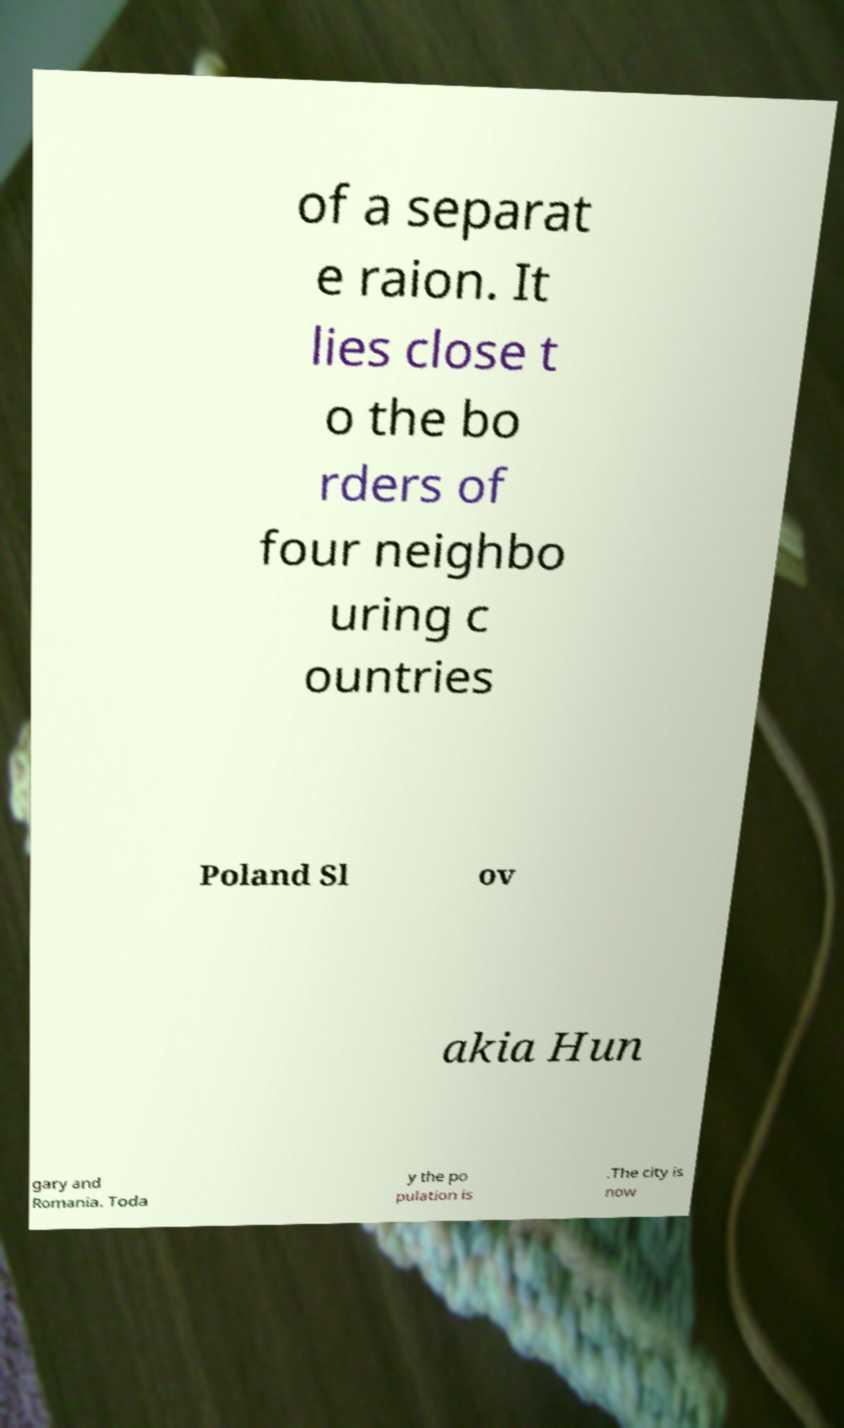Can you accurately transcribe the text from the provided image for me? of a separat e raion. It lies close t o the bo rders of four neighbo uring c ountries Poland Sl ov akia Hun gary and Romania. Toda y the po pulation is .The city is now 